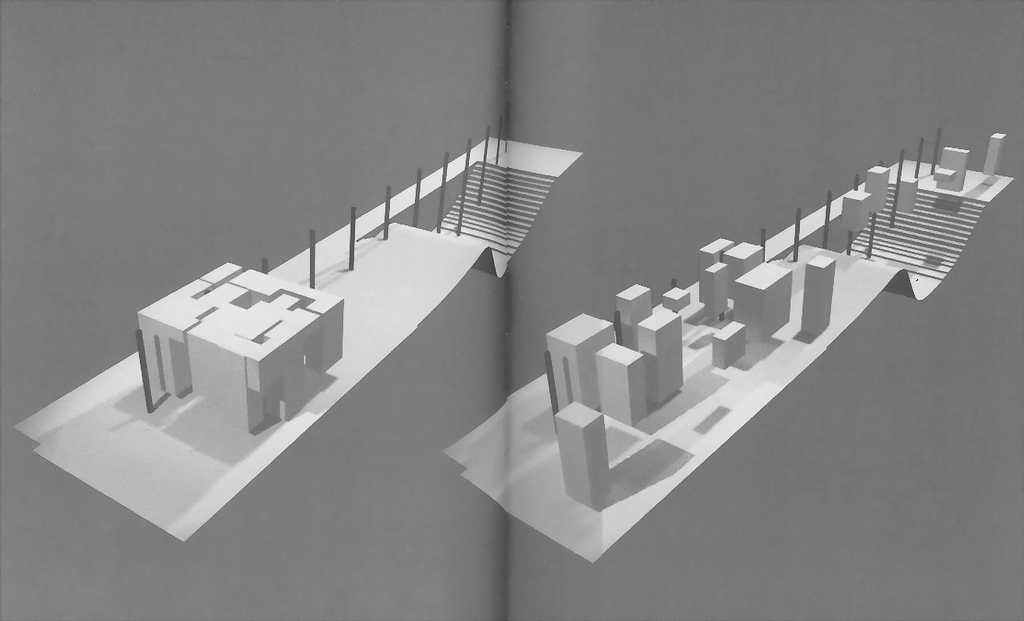What is depicted in the image? The image contains designs of buildings. Are there any architectural features visible in the image? Yes, there are stairs visible in the image. Where can the kittens be seen playing with the eggnog in the image? There are no kittens or eggnog present in the image; it only contains designs of buildings and stairs. 